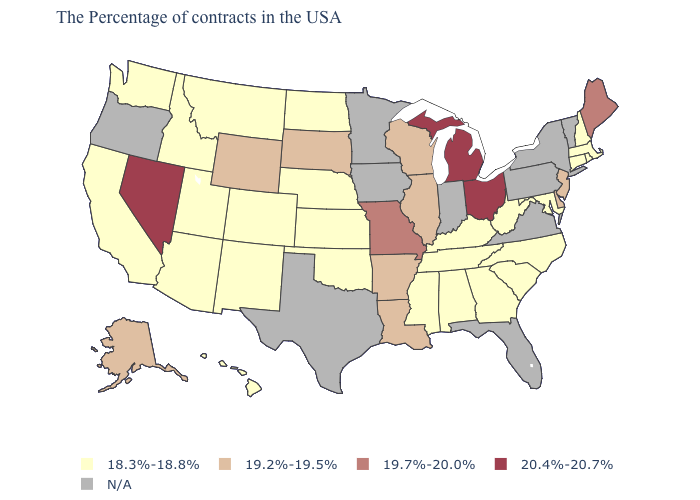Does North Carolina have the highest value in the USA?
Answer briefly. No. What is the highest value in the USA?
Keep it brief. 20.4%-20.7%. Which states have the lowest value in the USA?
Short answer required. Massachusetts, Rhode Island, New Hampshire, Connecticut, Maryland, North Carolina, South Carolina, West Virginia, Georgia, Kentucky, Alabama, Tennessee, Mississippi, Kansas, Nebraska, Oklahoma, North Dakota, Colorado, New Mexico, Utah, Montana, Arizona, Idaho, California, Washington, Hawaii. Does the map have missing data?
Short answer required. Yes. Name the states that have a value in the range 18.3%-18.8%?
Give a very brief answer. Massachusetts, Rhode Island, New Hampshire, Connecticut, Maryland, North Carolina, South Carolina, West Virginia, Georgia, Kentucky, Alabama, Tennessee, Mississippi, Kansas, Nebraska, Oklahoma, North Dakota, Colorado, New Mexico, Utah, Montana, Arizona, Idaho, California, Washington, Hawaii. What is the value of Indiana?
Give a very brief answer. N/A. Name the states that have a value in the range N/A?
Concise answer only. Vermont, New York, Pennsylvania, Virginia, Florida, Indiana, Minnesota, Iowa, Texas, Oregon. What is the highest value in the USA?
Quick response, please. 20.4%-20.7%. Which states have the highest value in the USA?
Be succinct. Ohio, Michigan, Nevada. Name the states that have a value in the range N/A?
Quick response, please. Vermont, New York, Pennsylvania, Virginia, Florida, Indiana, Minnesota, Iowa, Texas, Oregon. Is the legend a continuous bar?
Quick response, please. No. Does Michigan have the highest value in the USA?
Answer briefly. Yes. Which states hav the highest value in the South?
Give a very brief answer. Delaware, Louisiana, Arkansas. What is the highest value in the USA?
Short answer required. 20.4%-20.7%. 